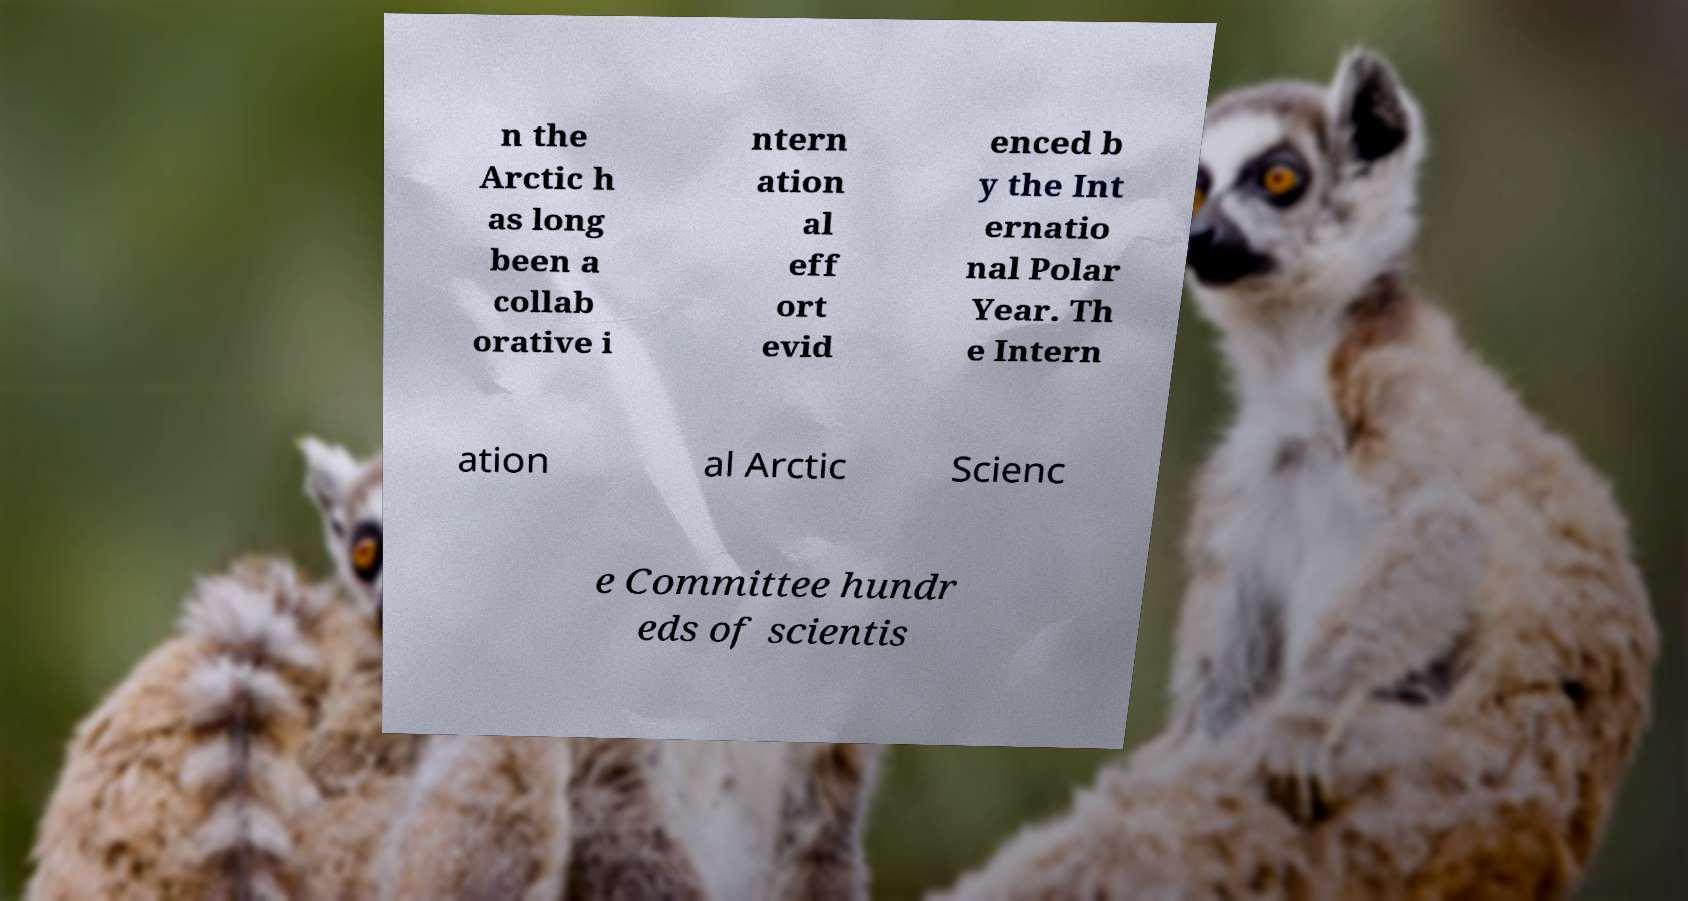Can you read and provide the text displayed in the image?This photo seems to have some interesting text. Can you extract and type it out for me? n the Arctic h as long been a collab orative i ntern ation al eff ort evid enced b y the Int ernatio nal Polar Year. Th e Intern ation al Arctic Scienc e Committee hundr eds of scientis 